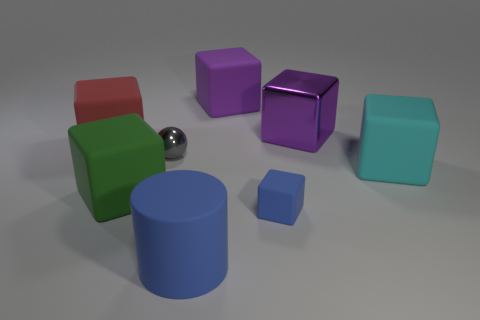Subtract 1 blocks. How many blocks are left? 5 Subtract all green cylinders. How many purple cubes are left? 2 Add 1 big rubber things. How many objects exist? 9 Subtract all large red matte cubes. How many cubes are left? 5 Subtract all cyan blocks. How many blocks are left? 5 Subtract all balls. How many objects are left? 7 Add 6 big blue objects. How many big blue objects are left? 7 Add 5 red rubber cubes. How many red rubber cubes exist? 6 Subtract 1 blue cylinders. How many objects are left? 7 Subtract all red cylinders. Subtract all gray spheres. How many cylinders are left? 1 